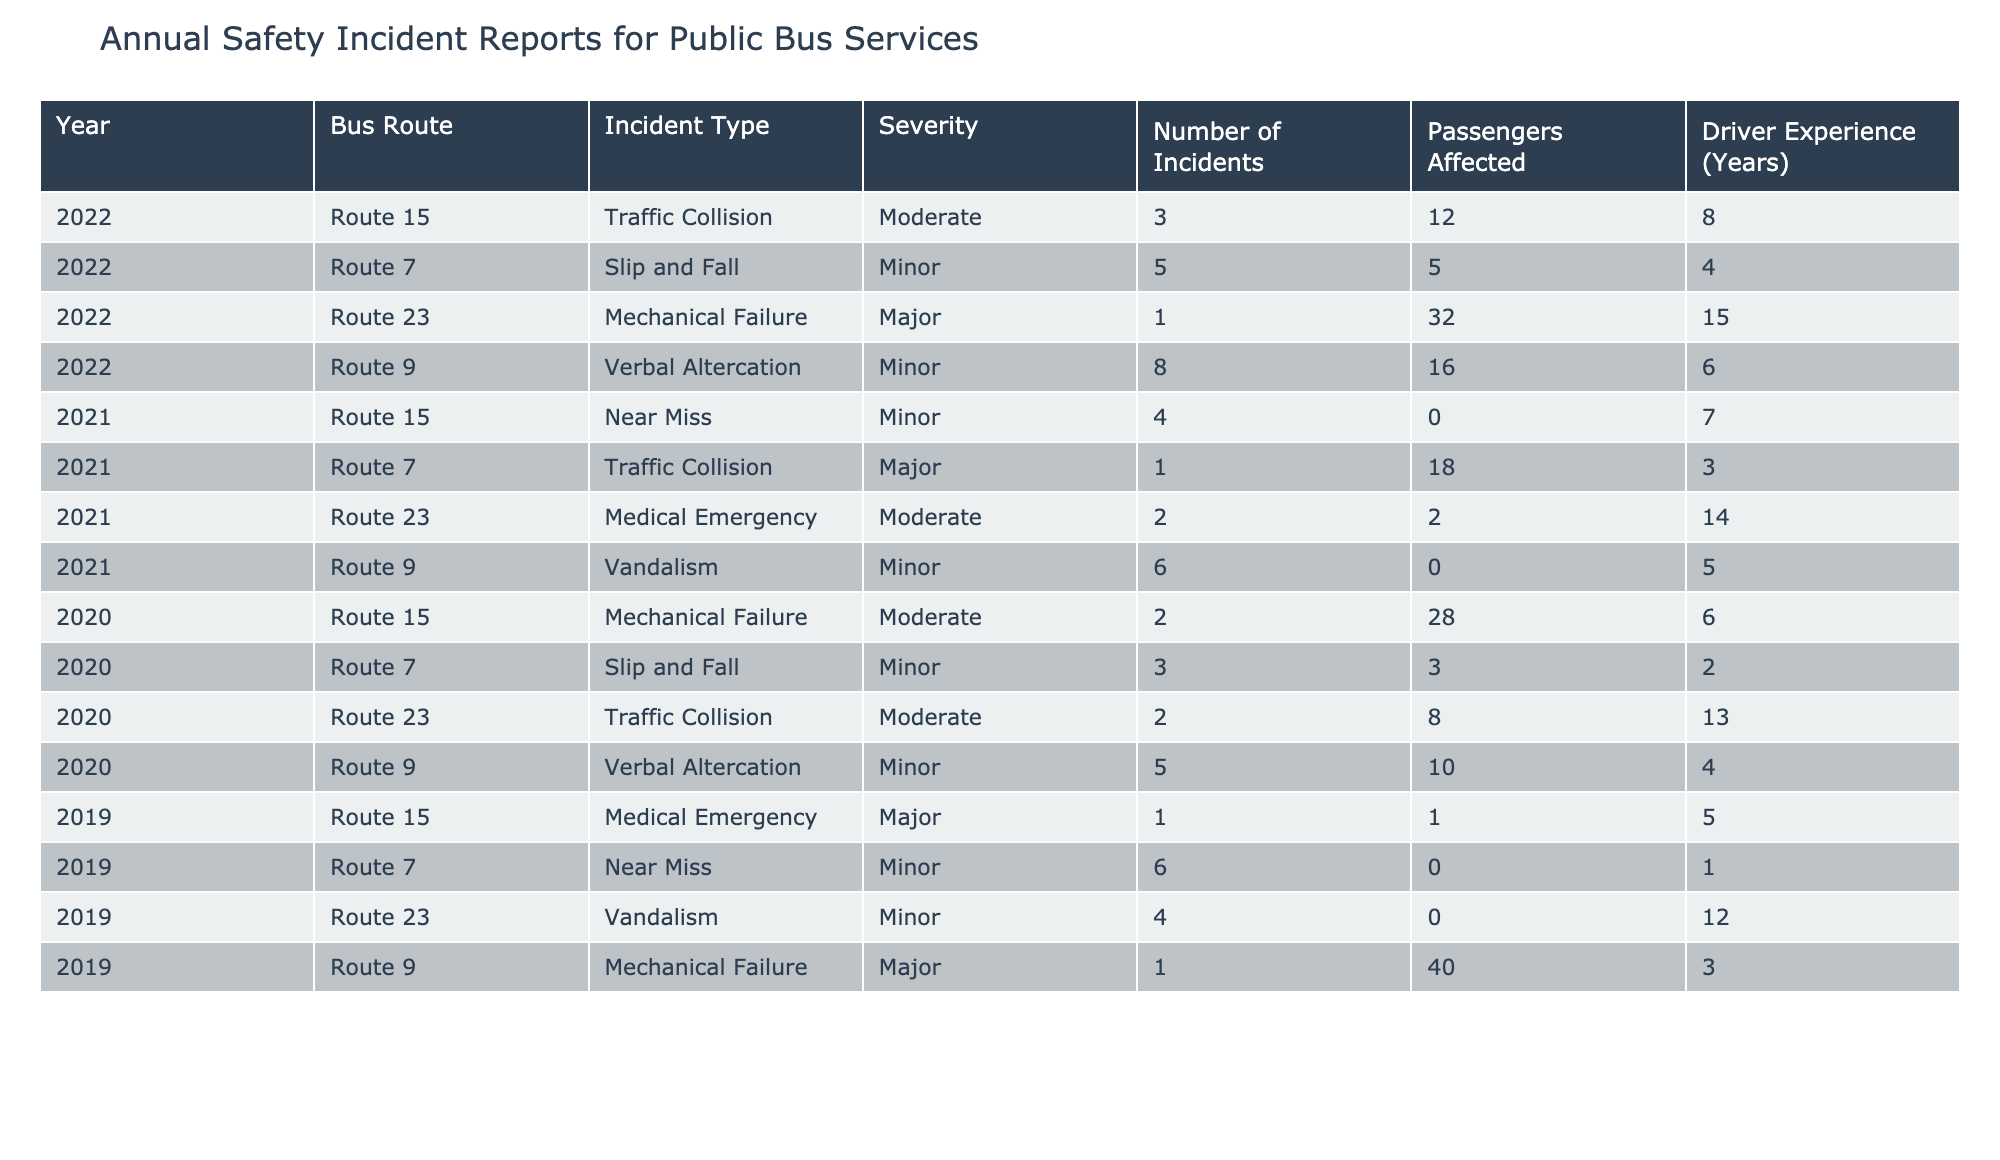What was the total number of incidents reported in 2022? By looking at the table, we find the number of incidents for the year 2022: Route 15 has 3, Route 7 has 5, Route 23 has 1, and Route 9 has 8. Adding these gives us 3 + 5 + 1 + 8 = 17 incidents in total for 2022.
Answer: 17 Which incident type had the highest severity in 2021? The incident types listed for 2021 are Near Miss, Traffic Collision, Medical Emergency, and Vandalism. The severity levels are Minor, Major, Moderate, and Minor respectively. The only Major severity incident is the Traffic Collision on Route 7, therefore it is the highest severity incident type for 2021.
Answer: Traffic Collision Did Route 23 have any Major incidents in 2022? Looking at the table for Route 23 in 2022, the only incident reported was Mechanical Failure, which has a severity listed as Major. Therefore, Route 23 had a Major incident in 2022.
Answer: Yes What is the average number of passengers affected by incidents on Route 9 across all years? We sum up the passengers affected for Route 9: in 2022, it was 16; in 2021, it was 0; in 2020, it was 10; in 2019, it was 40. So the total is 16 + 0 + 10 + 40 = 66. Since there are 4 data points, we divide by 4 to find the average: 66 / 4 = 16.5 passengers.
Answer: 16.5 For which bus route was the number of incidents the highest in 2021? Analyzing the number of incidents for each route in 2021: Route 15 had 4, Route 7 had 1, Route 23 had 2, and Route 9 had 6. The highest number of incidents is for Route 9 with 6 incidents.
Answer: Route 9 What is the trend in the number of incidents for Route 15 over the years presented? Reviewing the incidents for Route 15: in 2022 there were 3 incidents, in 2021 there were 4, and in 2020 there were 2. Observing the numbers, the trend shows an increase from 2 in 2020 to 3 in 2022, indicating a rise over the years.
Answer: Increasing Was there ever a year in which no incidents were reported for Route 7? Looking through the table, Route 7 shows incidents reported for every year listed (2022: 5, 2021: 1, 2020: 3, 2019: 6). Therefore, there was no year without incidents.
Answer: No What is the difference in the number of incidents between the years with the most and least incidents reported? In 2022, the total incidents were 17 and in 2019 the total was 11 (1 + 6 + 4 + 1). Thus, the difference is 17 - 11 = 6 incidents.
Answer: 6 Which incident type had the most occurrences across all years? We count the occurrences for each incident type: Traffic Collision (3), Slip and Fall (8), Mechanical Failure (4), Verbal Altercation (8), Near Miss (8), Medical Emergency (3), and Vandalism (4). The maximum occurrences come from Slip and Fall, Verbal Altercation, and Near Miss, each with 8 occurrences.
Answer: Slip and Fall (and others) In 2022, was there a relationship between driver experience and severity of incidents? In 2022, the incidents with driver experience were: Route 15 (8 years, Moderate), Route 7 (4 years, Minor), Route 23 (15 years, Major), and Route 9 (6 years, Minor). The incident with the highest severity (Major) had the highest driver experience (15 years). This indicates that higher driver experience correlates with increased severity in this specific case. However, a more comprehensive analysis would be needed across all data to establish a conclusive trend.
Answer: Yes, in this case 